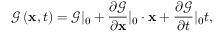<formula> <loc_0><loc_0><loc_500><loc_500>\ m a t h s c r { G } \left ( { x , t } \right ) = \ m a t h s c r { G } | _ { 0 } + \frac { \partial \ m a t h s c r { G } } { \partial x } | _ { 0 } \cdot x + \frac { \partial \ m a t h s c r { G } } { \partial t } | _ { 0 } t ,</formula> 